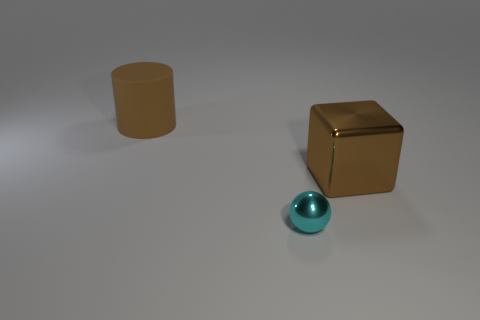Add 2 big rubber objects. How many objects exist? 5 Subtract all spheres. How many objects are left? 2 Add 1 brown things. How many brown things are left? 3 Add 3 red matte spheres. How many red matte spheres exist? 3 Subtract 0 green balls. How many objects are left? 3 Subtract all rubber things. Subtract all cylinders. How many objects are left? 1 